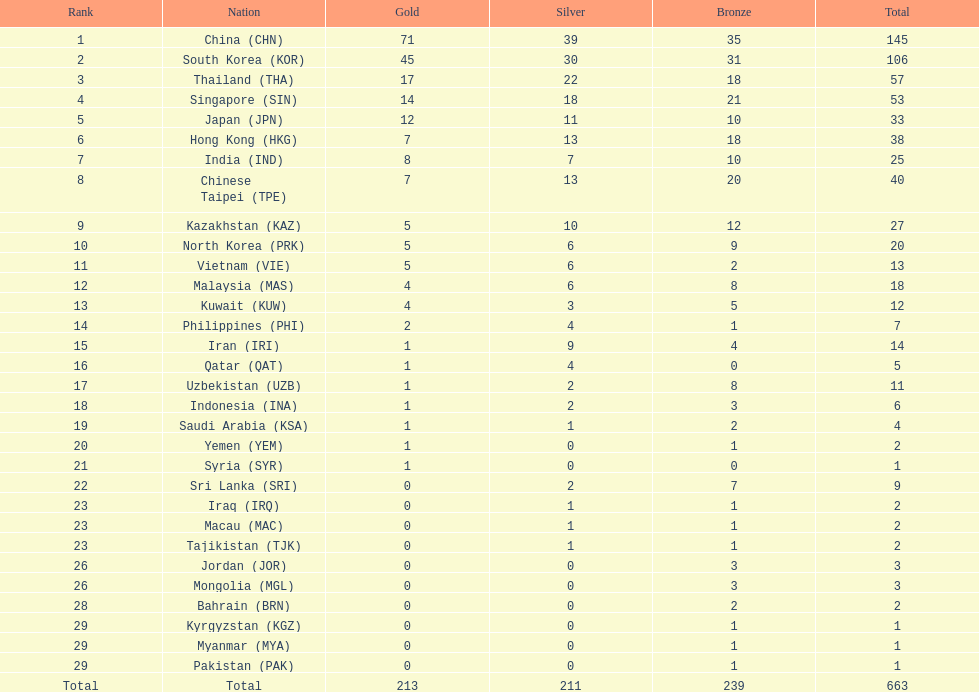What is the total number of medals that india won in the asian youth games? 25. 